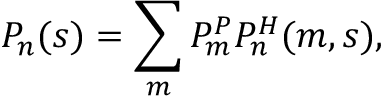Convert formula to latex. <formula><loc_0><loc_0><loc_500><loc_500>P _ { n } ( s ) = \sum _ { m } P _ { m } ^ { P } P _ { n } ^ { H } ( m , s ) ,</formula> 